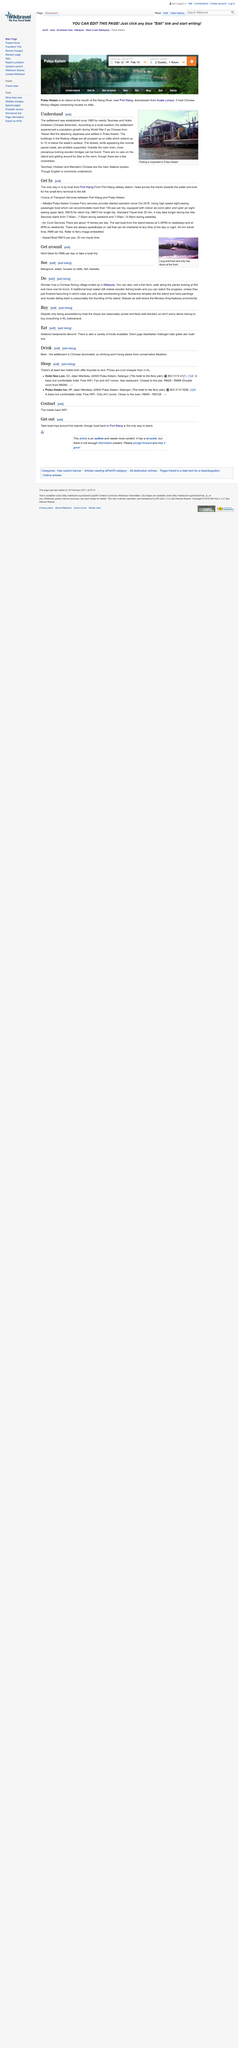Indicate a few pertinent items in this graphic. The cost for a return trip on the high speed passenger boat is 18 Malaysian Ringgit in local currency. The Teochew, Hokkien, and Mandarin Chinese dialects are the main ones spoken in . The buildings in the floating villages are propped up on stilts. The photograph in the accompanying image showcases the crucial activity of fishing, which is a significant aspect of many coastal communities. The passenger boat service takes 35 minutes, while the ferry service takes 40 minutes. 